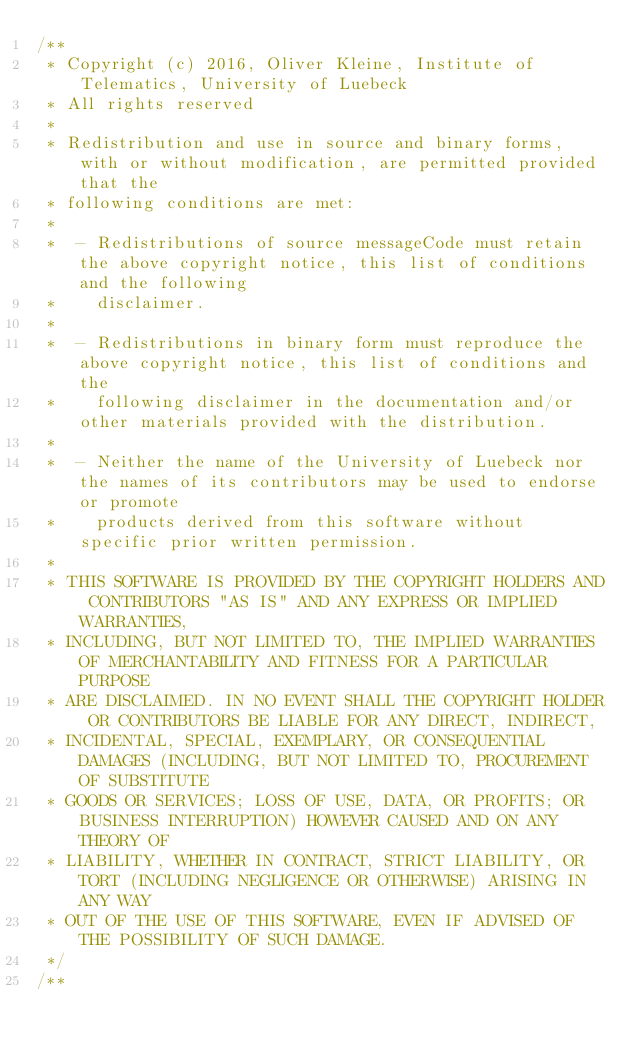Convert code to text. <code><loc_0><loc_0><loc_500><loc_500><_Java_>/**
 * Copyright (c) 2016, Oliver Kleine, Institute of Telematics, University of Luebeck
 * All rights reserved
 *
 * Redistribution and use in source and binary forms, with or without modification, are permitted provided that the
 * following conditions are met:
 *
 *  - Redistributions of source messageCode must retain the above copyright notice, this list of conditions and the following
 *    disclaimer.
 *
 *  - Redistributions in binary form must reproduce the above copyright notice, this list of conditions and the
 *    following disclaimer in the documentation and/or other materials provided with the distribution.
 *
 *  - Neither the name of the University of Luebeck nor the names of its contributors may be used to endorse or promote
 *    products derived from this software without specific prior written permission.
 *
 * THIS SOFTWARE IS PROVIDED BY THE COPYRIGHT HOLDERS AND CONTRIBUTORS "AS IS" AND ANY EXPRESS OR IMPLIED WARRANTIES,
 * INCLUDING, BUT NOT LIMITED TO, THE IMPLIED WARRANTIES OF MERCHANTABILITY AND FITNESS FOR A PARTICULAR PURPOSE
 * ARE DISCLAIMED. IN NO EVENT SHALL THE COPYRIGHT HOLDER OR CONTRIBUTORS BE LIABLE FOR ANY DIRECT, INDIRECT,
 * INCIDENTAL, SPECIAL, EXEMPLARY, OR CONSEQUENTIAL DAMAGES (INCLUDING, BUT NOT LIMITED TO, PROCUREMENT OF SUBSTITUTE
 * GOODS OR SERVICES; LOSS OF USE, DATA, OR PROFITS; OR BUSINESS INTERRUPTION) HOWEVER CAUSED AND ON ANY THEORY OF
 * LIABILITY, WHETHER IN CONTRACT, STRICT LIABILITY, OR TORT (INCLUDING NEGLIGENCE OR OTHERWISE) ARISING IN ANY WAY
 * OUT OF THE USE OF THIS SOFTWARE, EVEN IF ADVISED OF THE POSSIBILITY OF SUCH DAMAGE.
 */
/**</code> 